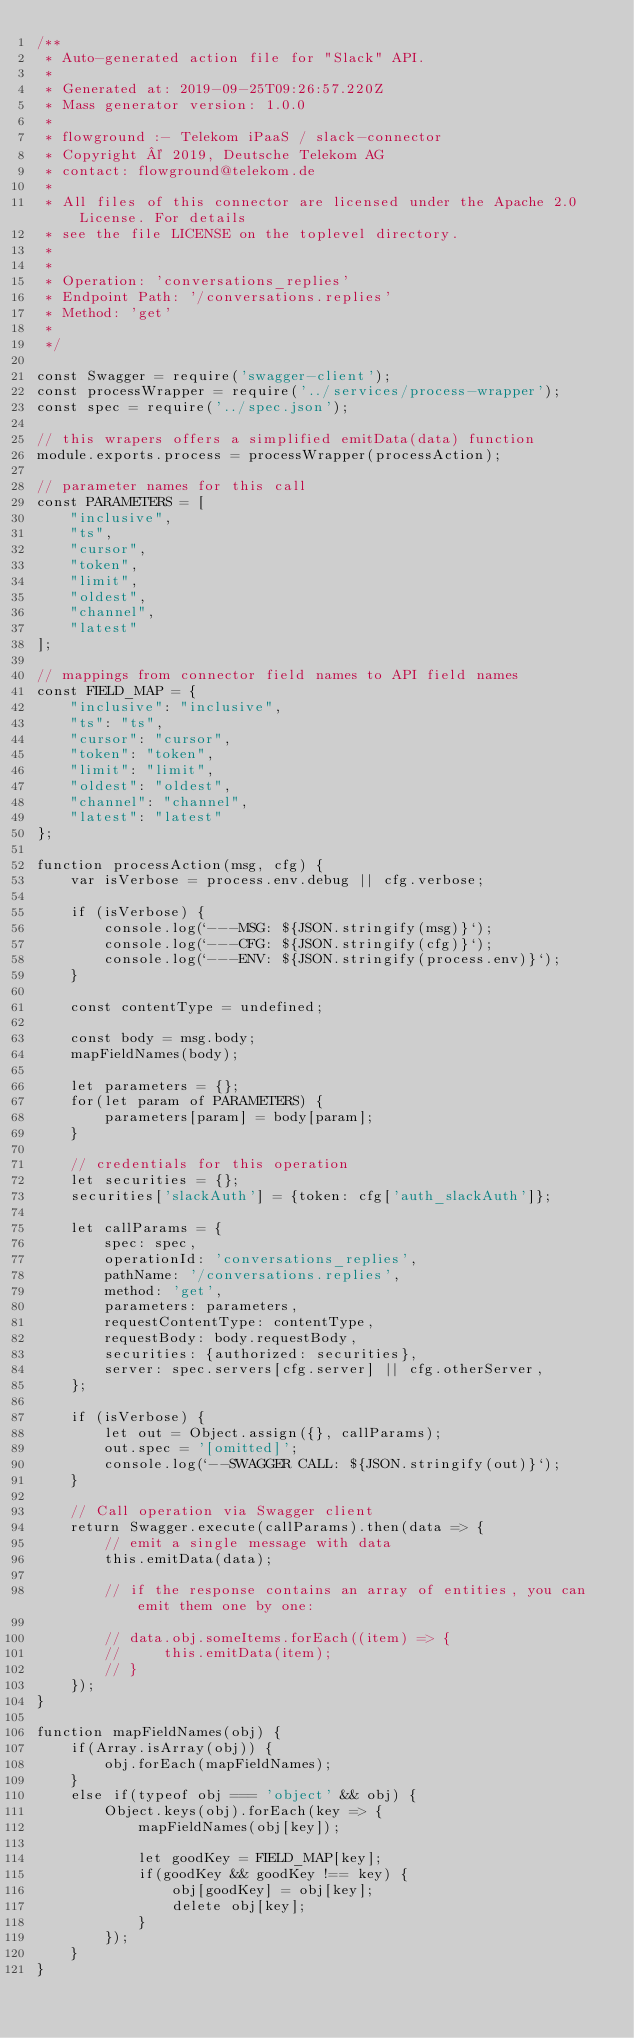<code> <loc_0><loc_0><loc_500><loc_500><_JavaScript_>/**
 * Auto-generated action file for "Slack" API.
 *
 * Generated at: 2019-09-25T09:26:57.220Z
 * Mass generator version: 1.0.0
 *
 * flowground :- Telekom iPaaS / slack-connector
 * Copyright © 2019, Deutsche Telekom AG
 * contact: flowground@telekom.de
 *
 * All files of this connector are licensed under the Apache 2.0 License. For details
 * see the file LICENSE on the toplevel directory.
 *
 *
 * Operation: 'conversations_replies'
 * Endpoint Path: '/conversations.replies'
 * Method: 'get'
 *
 */

const Swagger = require('swagger-client');
const processWrapper = require('../services/process-wrapper');
const spec = require('../spec.json');

// this wrapers offers a simplified emitData(data) function
module.exports.process = processWrapper(processAction);

// parameter names for this call
const PARAMETERS = [
    "inclusive",
    "ts",
    "cursor",
    "token",
    "limit",
    "oldest",
    "channel",
    "latest"
];

// mappings from connector field names to API field names
const FIELD_MAP = {
    "inclusive": "inclusive",
    "ts": "ts",
    "cursor": "cursor",
    "token": "token",
    "limit": "limit",
    "oldest": "oldest",
    "channel": "channel",
    "latest": "latest"
};

function processAction(msg, cfg) {
    var isVerbose = process.env.debug || cfg.verbose;

    if (isVerbose) {
        console.log(`---MSG: ${JSON.stringify(msg)}`);
        console.log(`---CFG: ${JSON.stringify(cfg)}`);
        console.log(`---ENV: ${JSON.stringify(process.env)}`);
    }

    const contentType = undefined;

    const body = msg.body;
    mapFieldNames(body);

    let parameters = {};
    for(let param of PARAMETERS) {
        parameters[param] = body[param];
    }

    // credentials for this operation
    let securities = {};
    securities['slackAuth'] = {token: cfg['auth_slackAuth']};

    let callParams = {
        spec: spec,
        operationId: 'conversations_replies',
        pathName: '/conversations.replies',
        method: 'get',
        parameters: parameters,
        requestContentType: contentType,
        requestBody: body.requestBody,
        securities: {authorized: securities},
        server: spec.servers[cfg.server] || cfg.otherServer,
    };

    if (isVerbose) {
        let out = Object.assign({}, callParams);
        out.spec = '[omitted]';
        console.log(`--SWAGGER CALL: ${JSON.stringify(out)}`);
    }

    // Call operation via Swagger client
    return Swagger.execute(callParams).then(data => {
        // emit a single message with data
        this.emitData(data);

        // if the response contains an array of entities, you can emit them one by one:

        // data.obj.someItems.forEach((item) => {
        //     this.emitData(item);
        // }
    });
}

function mapFieldNames(obj) {
    if(Array.isArray(obj)) {
        obj.forEach(mapFieldNames);
    }
    else if(typeof obj === 'object' && obj) {
        Object.keys(obj).forEach(key => {
            mapFieldNames(obj[key]);

            let goodKey = FIELD_MAP[key];
            if(goodKey && goodKey !== key) {
                obj[goodKey] = obj[key];
                delete obj[key];
            }
        });
    }
}</code> 